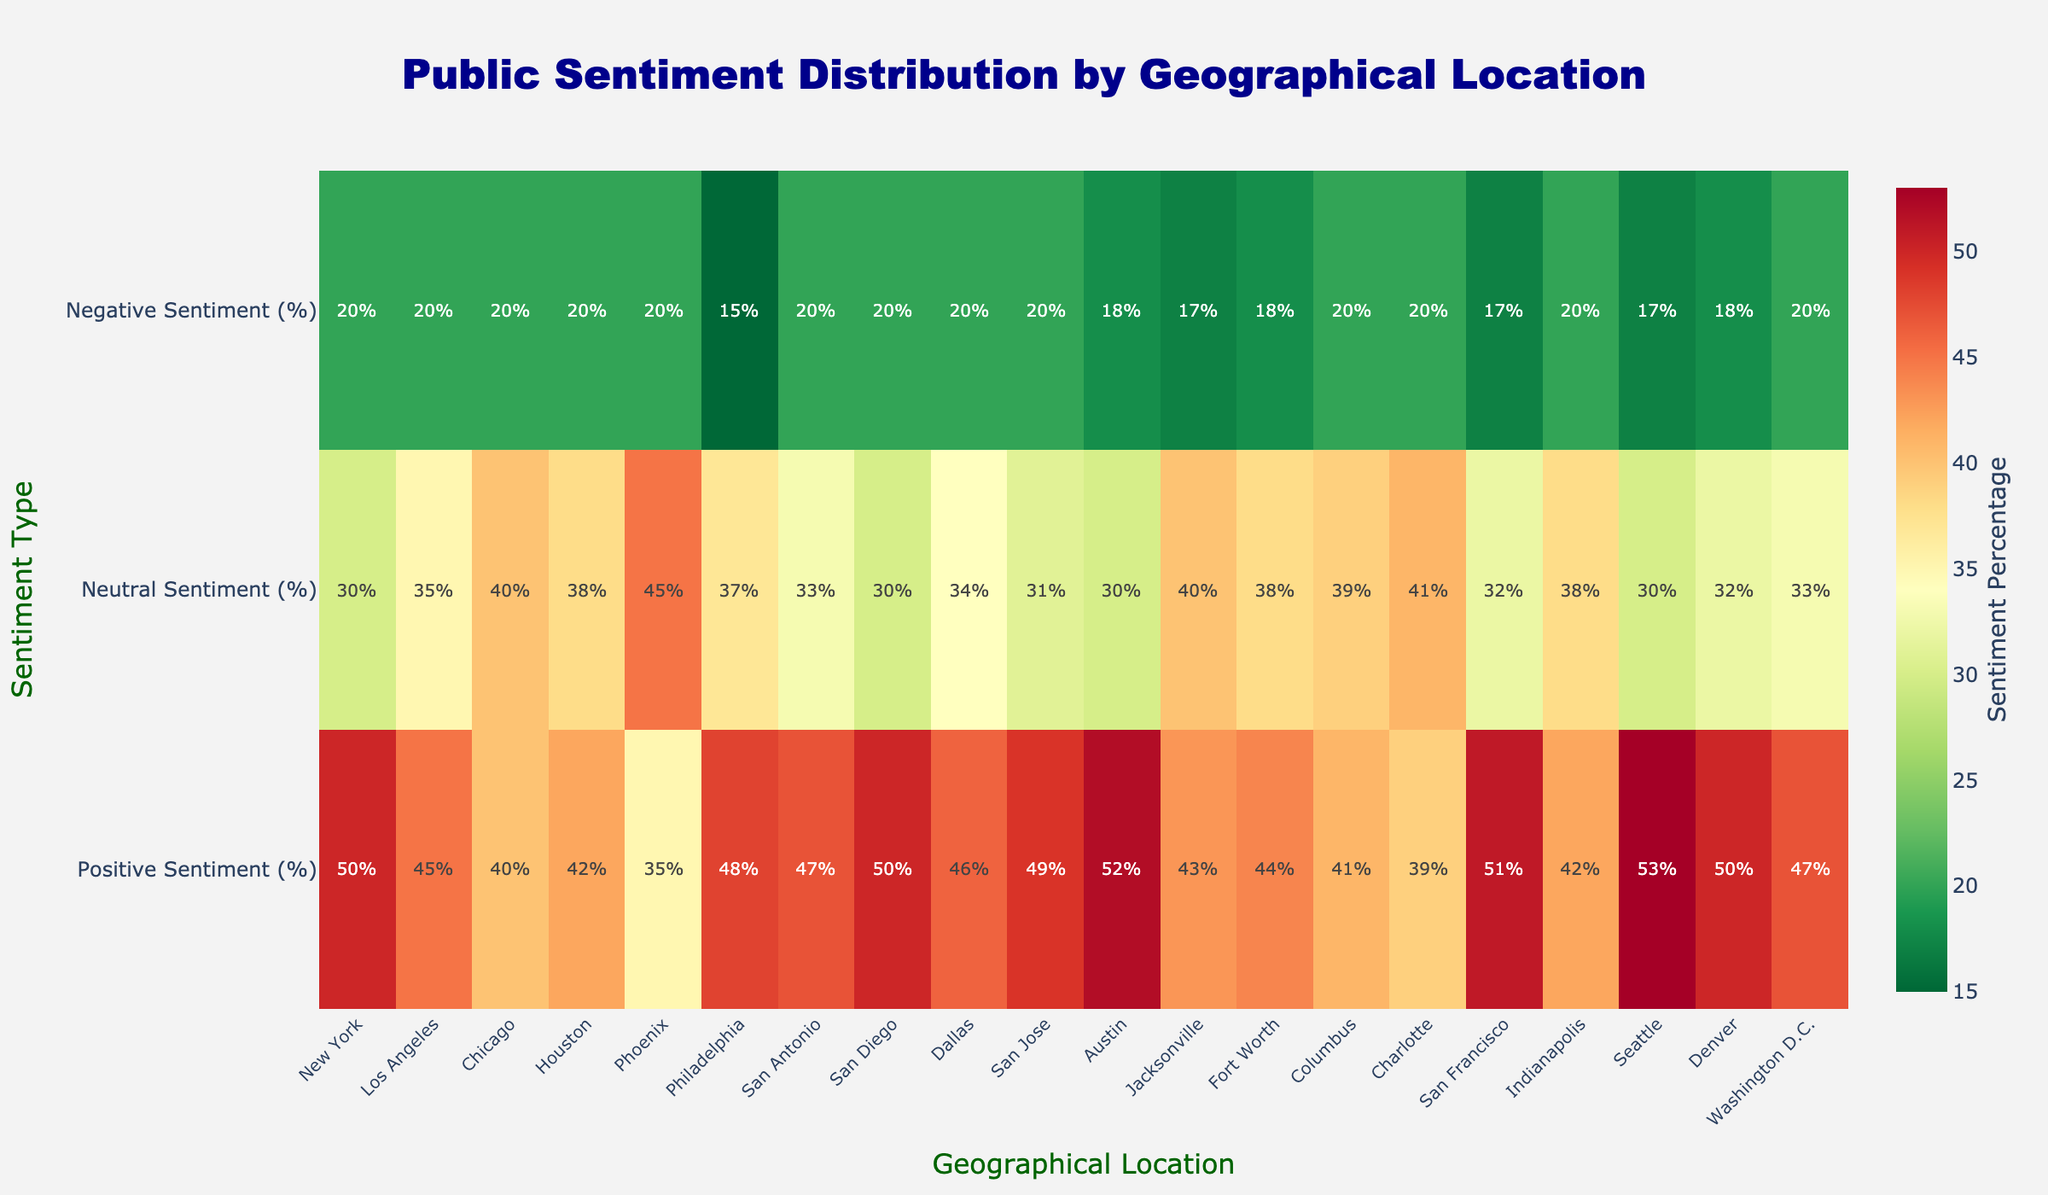What is the title of the heatmap? The title of the heatmap is prominently displayed at the top center of the figure.
Answer: Public Sentiment Distribution by Geographical Location What is the percentage of positive sentiment in Seattle? Locate the 'Seattle' column in the 'Positive Sentiment (%)' row.
Answer: 53% Which city has the highest percentage of negative sentiment? Compare the 'Negative Sentiment (%)' values across all cities and identify the highest.
Answer: All cities have 20%, except Philadelphia, Austin, San Francisco, Seattle, Denver which have 17%, 18%, 17%, 17%, 18% respectively; meaning 20% is the maximum Which city has the lowest percentage of neutral sentiment? Compare the 'Neutral Sentiment (%)' values across all the cities and identify the lowest.
Answer: Austin and Seattle both have 30% Which city has both the highest positive and neutral sentiment? Identify the city with both the highest percentages under 'Positive Sentiment (%)' and 'Neutral Sentiment (%)'.
Answer: Not possible as no city has the highest in both categories What is the average positive sentiment percentage across all cities? Sum up the positive sentiment percentages for all cities and divide by the number of cities. (Sum = 982, Number of Cities = 20, Average = 982/20)
Answer: 49.1% Which city has the smallest difference between positive and neutral sentiments? Calculate the absolute difference between positive and neutral percentages for each city and identify the smallest.
Answer: Houston, with (42-38)=4 How does San Francisco's positive sentiment compare to that of Los Angeles? Compare the values for 'Positive Sentiment (%)' for San Francisco and Los Angeles.
Answer: San Francisco has a higher positive sentiment (51% vs 45%) Among New York and Washington D.C., which city has a higher neutral sentiment? Compare the 'Neutral Sentiment (%)' values for New York and Washington D.C.
Answer: New York with 30%, over D.C's 33% Which sentiment type has the widest range of percentages across all cities? Calculate the range (max-min) for positive, neutral, and negative sentiments and compare.
Answer: Positive Sentiment (53%-35%=18%), Neutral Sentiment (45%-30%=15%), Negative Sentiment (20%-17%=3%), hence Positive Sentiment has the widest 